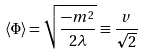<formula> <loc_0><loc_0><loc_500><loc_500>\langle \Phi \rangle = \sqrt { \frac { - m ^ { 2 } } { 2 \lambda } } \equiv \frac { v } { \sqrt { 2 } }</formula> 